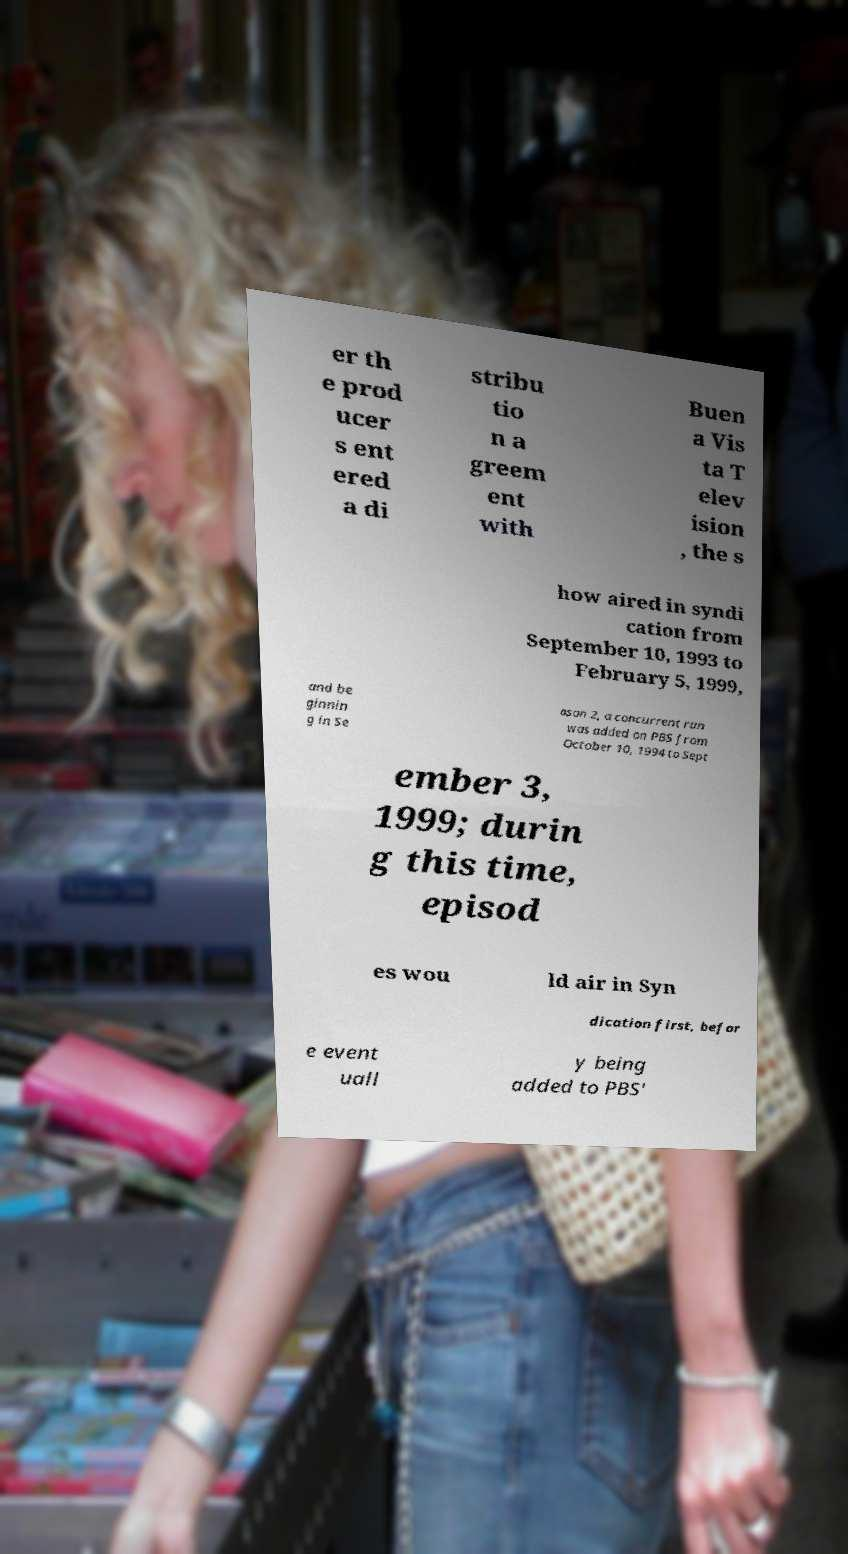Please identify and transcribe the text found in this image. er th e prod ucer s ent ered a di stribu tio n a greem ent with Buen a Vis ta T elev ision , the s how aired in syndi cation from September 10, 1993 to February 5, 1999, and be ginnin g in Se ason 2, a concurrent run was added on PBS from October 10, 1994 to Sept ember 3, 1999; durin g this time, episod es wou ld air in Syn dication first, befor e event uall y being added to PBS' 